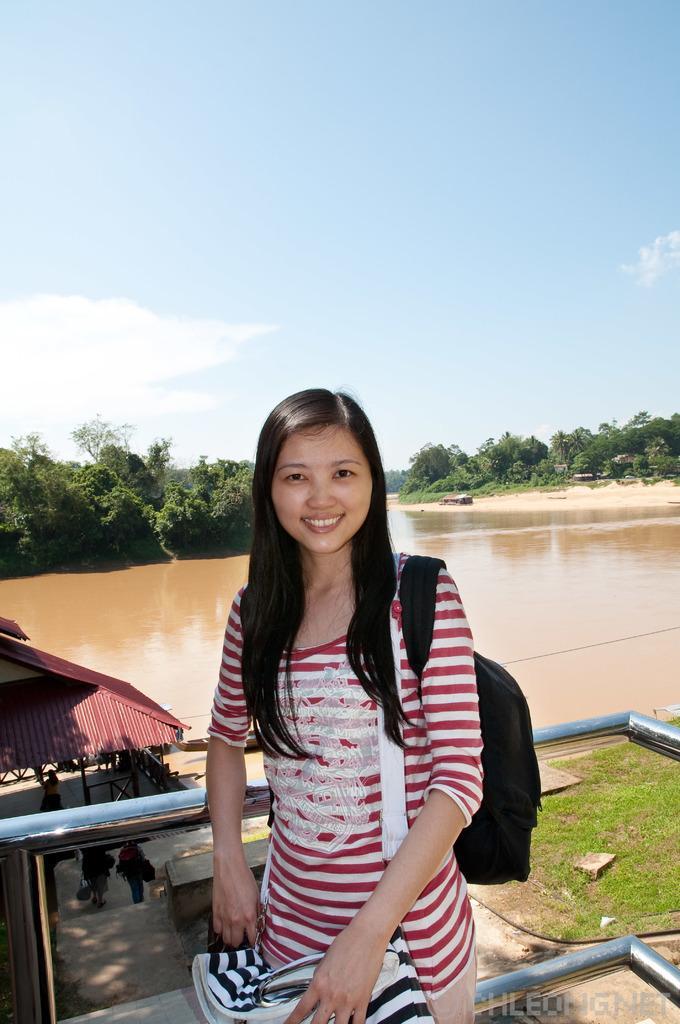In one or two sentences, can you explain what this image depicts? In this image I see a girl who is standing and I see that she is smiling and I see that she is wearing white and red color dress and she is wearing a bag and I see the railing. In the background I see the grass and I see the path over here and I see few more people over here and I see the water. I can also see number of trees and I see the clear sky and I see the watermark over here. 